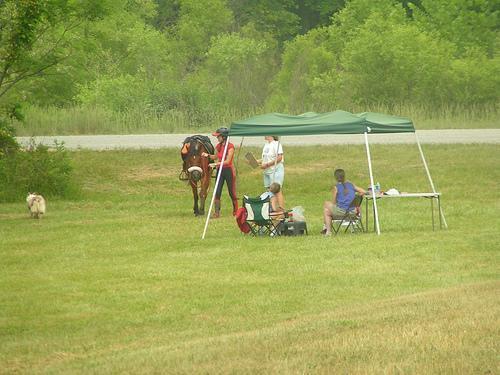How many people are here?
Give a very brief answer. 4. How many laptops do you see?
Give a very brief answer. 0. 